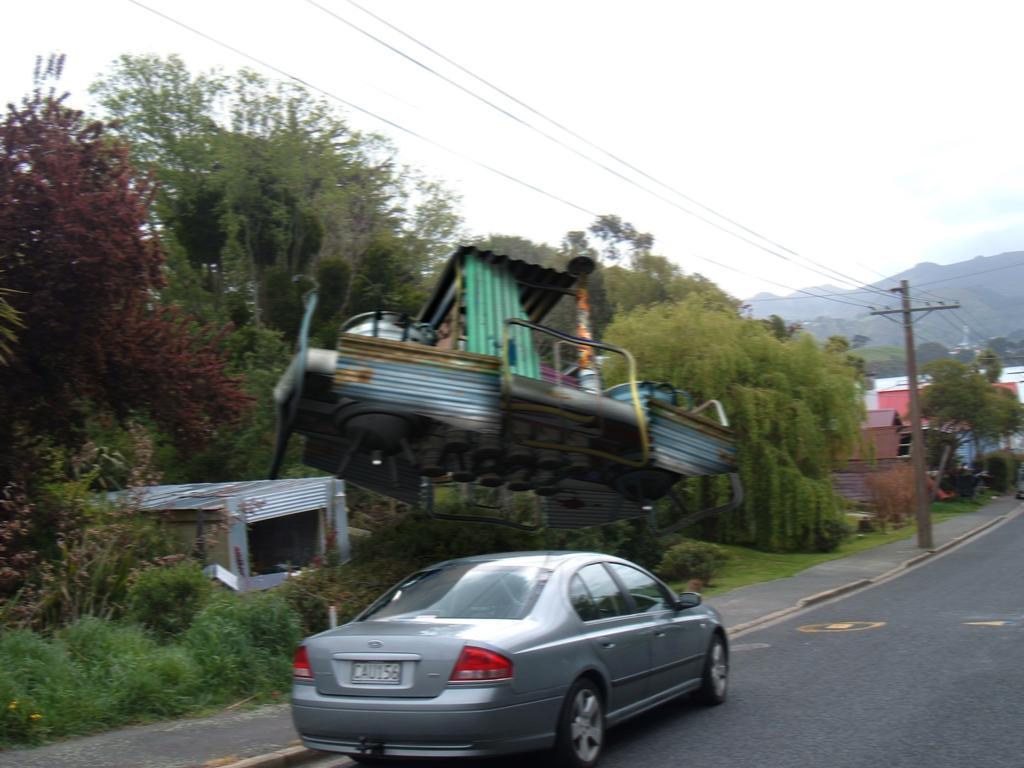Describe this image in one or two sentences. In this image we can see sky with clouds, hills, electric poles, electric cables, buildings, creepers, trees, shrubs, motor vehicle on the road and a shed. 